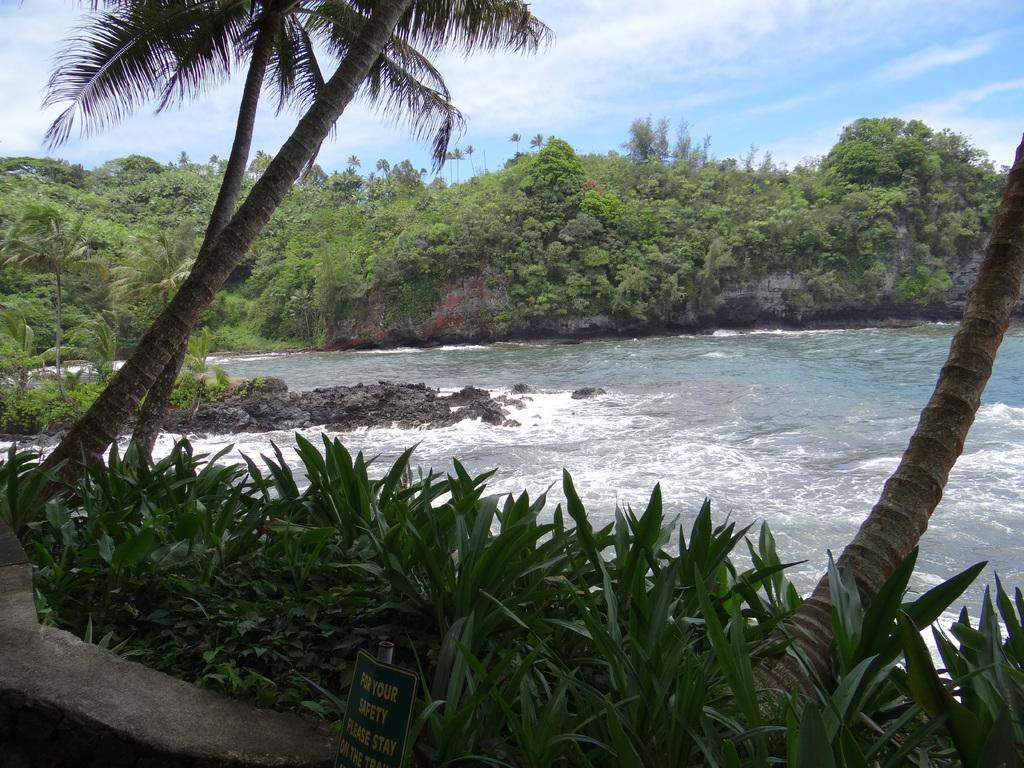What is the main object in the image? There is a board in the image. What can be seen at the bottom of the image? There are plants at the bottom of the image. What is located in the middle of the image? There is water in the middle of the image. What type of vegetation is visible in the background of the image? There are trees in the background of the image. What is visible at the top of the image? The sky is visible at the top of the image. What type of knife is being used to cut the metal in the image? There is no knife or metal present in the image; it features a board, plants, water, trees, and the sky. 